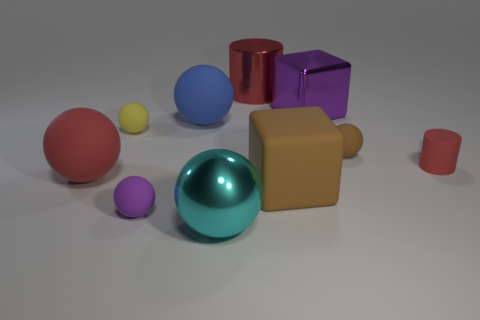The big cylinder that is the same material as the purple cube is what color?
Provide a succinct answer. Red. There is a purple object on the right side of the cyan metallic object; does it have the same size as the cyan metal sphere?
Provide a short and direct response. Yes. The metal thing that is the same shape as the blue rubber thing is what color?
Provide a short and direct response. Cyan. There is a small brown matte object behind the sphere in front of the purple thing that is in front of the tiny yellow rubber sphere; what is its shape?
Your answer should be very brief. Sphere. Is the shape of the tiny yellow thing the same as the large cyan object?
Provide a succinct answer. Yes. The purple object that is in front of the small ball that is on the right side of the shiny ball is what shape?
Keep it short and to the point. Sphere. Is there a big rubber object?
Your answer should be very brief. Yes. What number of large things are behind the cube that is behind the cube in front of the yellow thing?
Make the answer very short. 1. There is a tiny purple rubber thing; is it the same shape as the large rubber thing that is in front of the big red sphere?
Your answer should be very brief. No. Is the number of brown metallic cubes greater than the number of tiny purple objects?
Provide a succinct answer. No. 